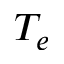<formula> <loc_0><loc_0><loc_500><loc_500>T _ { e }</formula> 